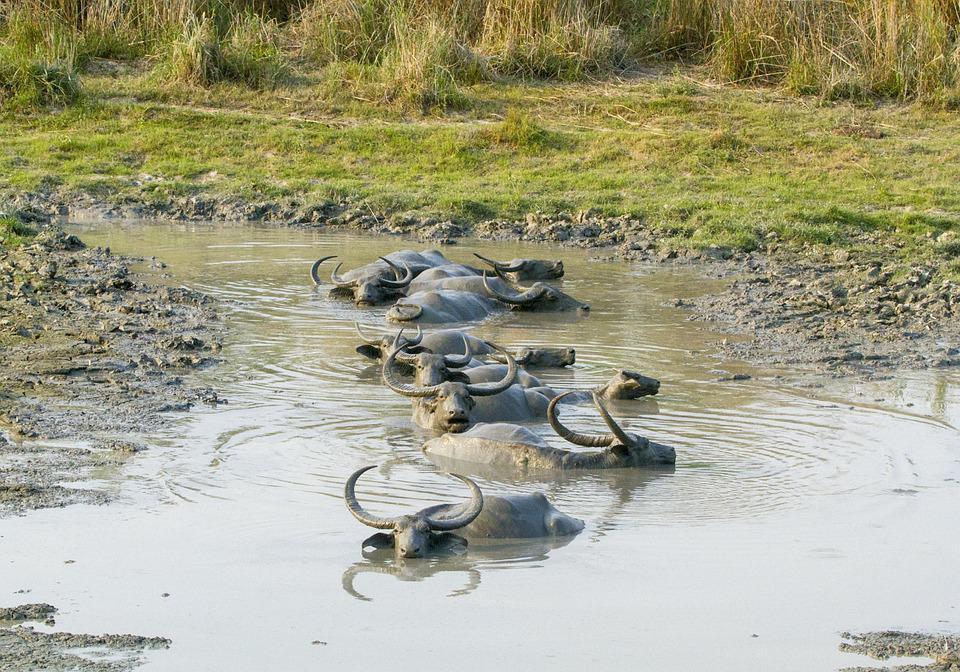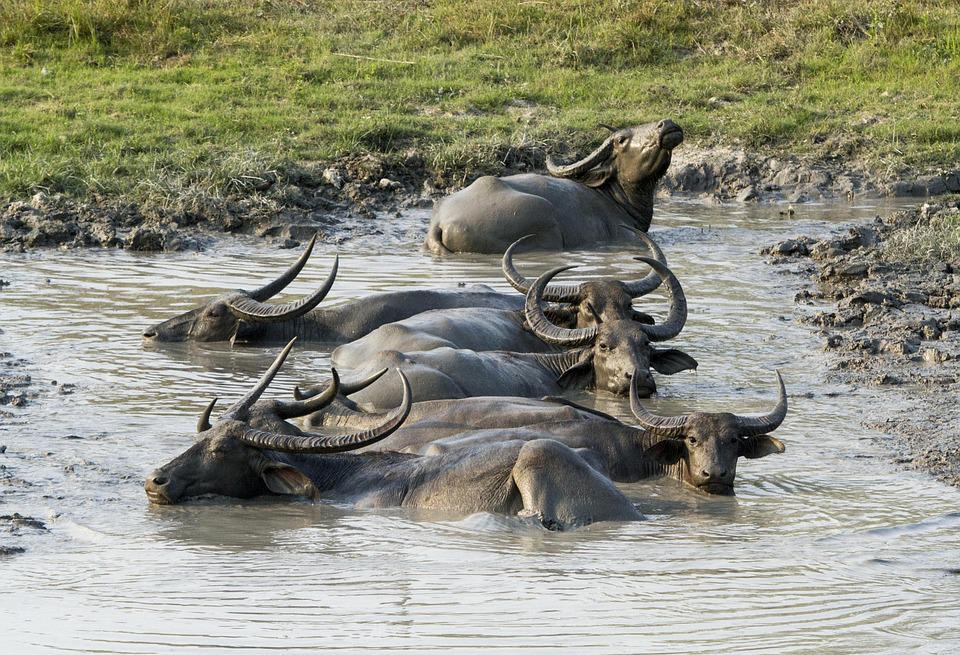The first image is the image on the left, the second image is the image on the right. Examine the images to the left and right. Is the description "There are at least four adult buffalos having a mud bath." accurate? Answer yes or no. Yes. The first image is the image on the left, the second image is the image on the right. Assess this claim about the two images: "An image shows exactly one water buffalo in a muddy pit, with its head turned forward.". Correct or not? Answer yes or no. No. 